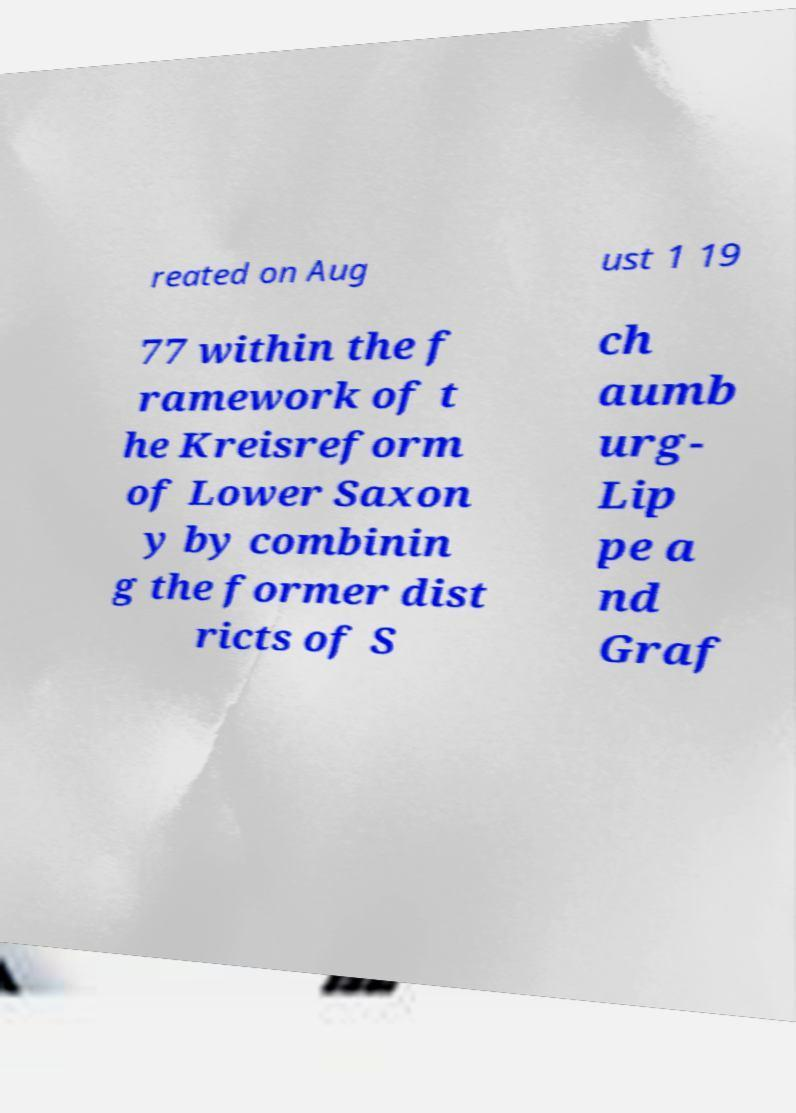Could you assist in decoding the text presented in this image and type it out clearly? reated on Aug ust 1 19 77 within the f ramework of t he Kreisreform of Lower Saxon y by combinin g the former dist ricts of S ch aumb urg- Lip pe a nd Graf 